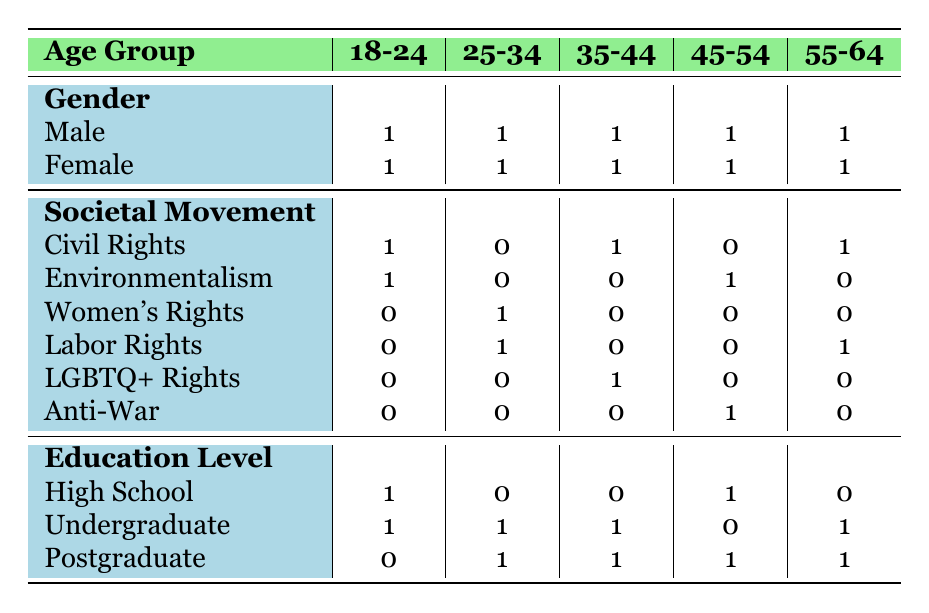What is the total number of male residents involved in all societal movements? There are five male residents: one each in the age groups of 18-24, 25-34, 35-44, 45-54, and 55-64. Summing them up gives a total of 5 male residents.
Answer: 5 How many residents aged 35-44 are involved in LGBTQ+ rights? According to the table, there is one female resident in the 35-44 age group involved in LGBTQ+ rights.
Answer: 1 Is there any resident with a high school education level involved in Women's Rights? Looking at the table, there are no residents listed with a high school education level who are involved in Women's Rights.
Answer: No What is the total number of female residents involved in Labor Rights across all age groups? The table shows two females involved in Labor Rights: one in the age group of 25-34 and one in the age group of 55-64. Adding these gives a total of 2 female residents involved in Labor Rights.
Answer: 2 Which societal movement has the highest representation from individuals with a postgraduate education? The movements with postgraduate representation are Environmentalism, Women's Rights, LGBTQ+ Rights, and Labor Rights. Each has one postgraduate involved, hence there are no movements with higher representation than one.
Answer: None How many total residents are involved in civil rights movements across all age groups? From the table, there are three civil rights residents: one in 18-24, one in 35-44, and one in 55-64, summing these results gives a total of 3 involved in civil rights.
Answer: 3 Are there any residents aged 45-54 involved in Environmentalism? The table indicates that there is one male resident aged 45-54 involved in Environmentalism.
Answer: Yes How many residents are there in total in the age group of 25-34? By counting the entries in the 25-34 age group, there are two residents: one male involved in Labor Rights and one female involved in Women's Rights. Thus, the total number is 2.
Answer: 2 What is the ratio of male to female residents involved in Anti-War movements? The table shows that only one female resident aged 45-54 is involved in Anti-War. There are no male residents in this movement, so the ratio is 1:0.
Answer: 1:0 